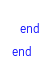Convert code to text. <code><loc_0><loc_0><loc_500><loc_500><_Ruby_>  end
end
</code> 